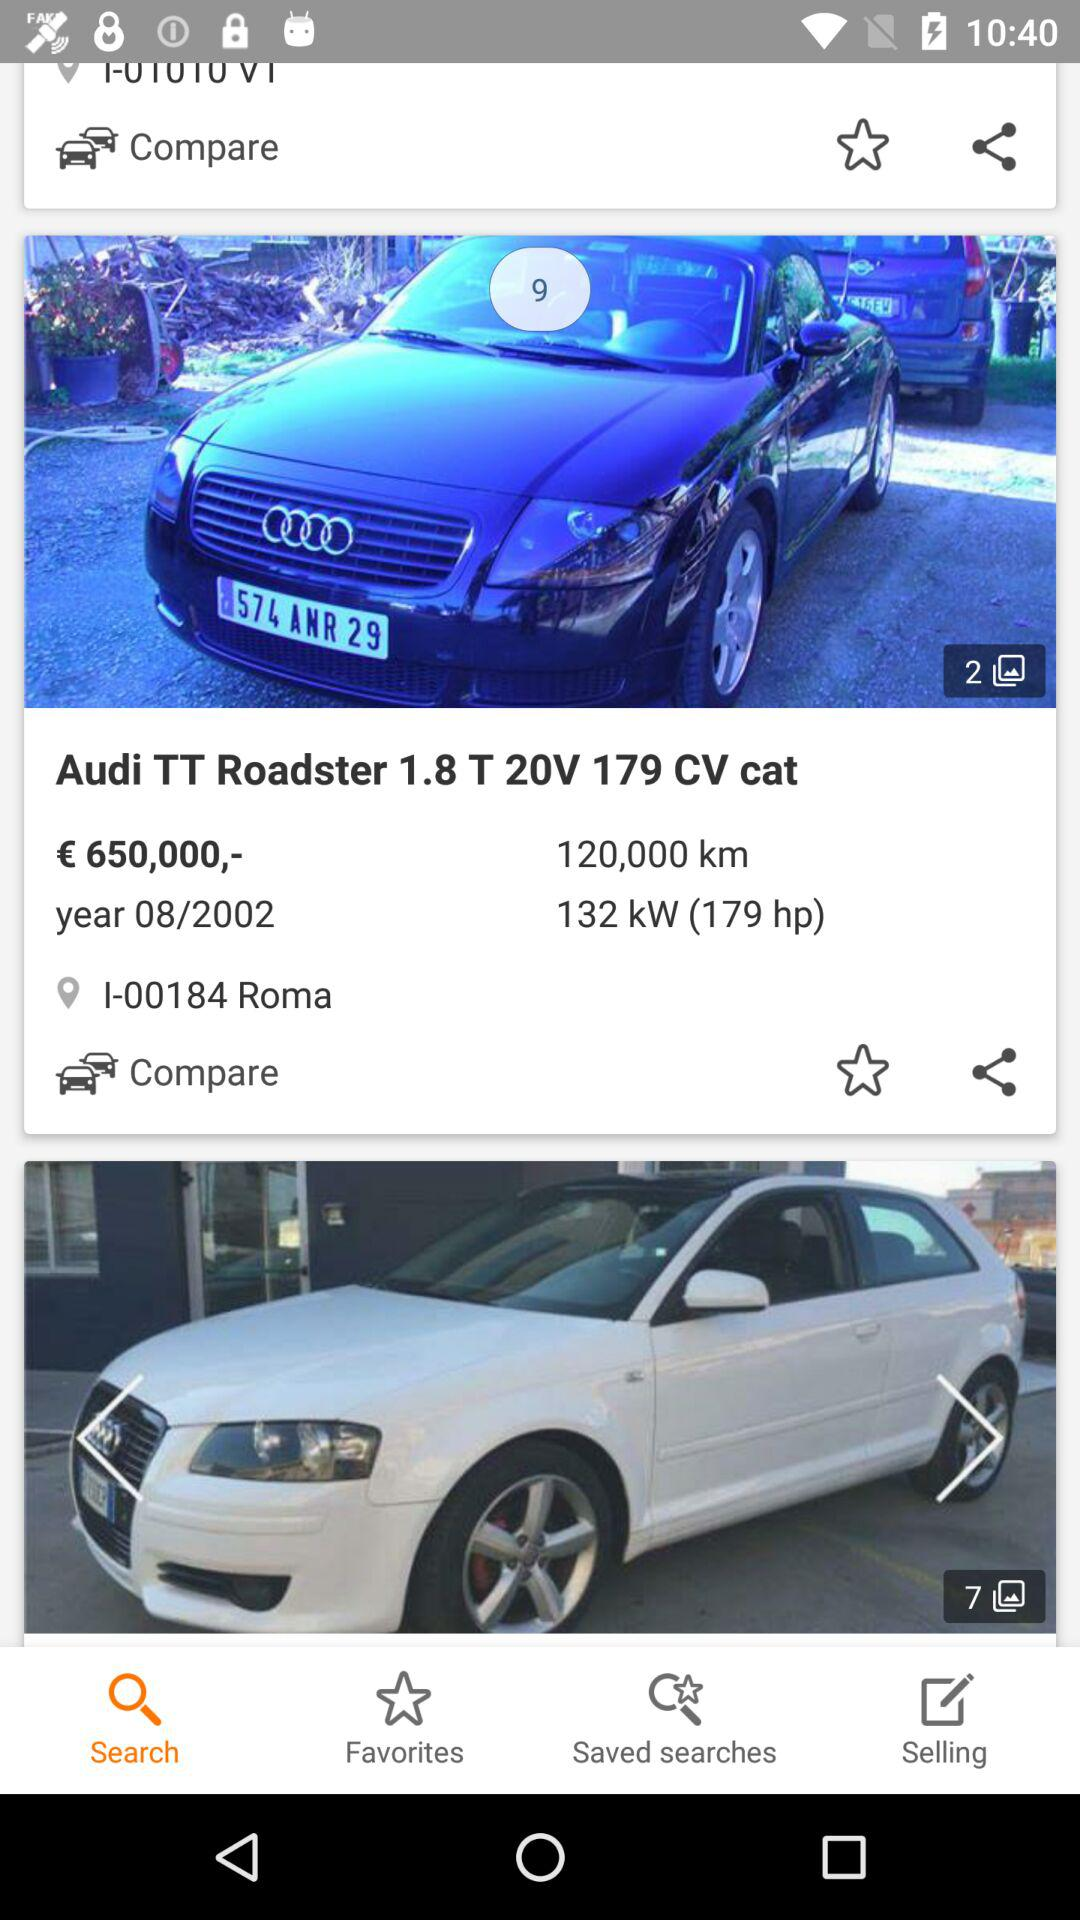How many images in total are there of the "Audi TT Roadster"? There are 2 images. 